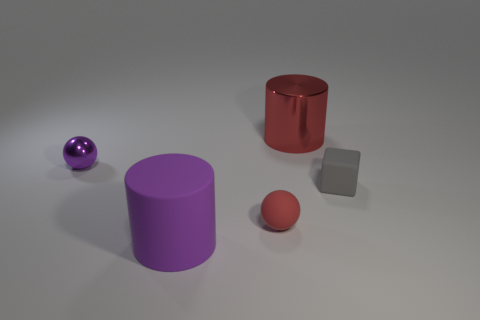Is there any other thing that has the same size as the red matte ball?
Provide a succinct answer. Yes. What size is the purple matte cylinder?
Provide a succinct answer. Large. How many big things are either rubber cubes or red metal balls?
Your response must be concise. 0. There is a purple shiny sphere; is it the same size as the cylinder on the right side of the big rubber object?
Give a very brief answer. No. Is there anything else that has the same shape as the purple metal thing?
Make the answer very short. Yes. How many gray matte cubes are there?
Ensure brevity in your answer.  1. How many cyan objects are large things or tiny rubber balls?
Make the answer very short. 0. Do the red object behind the red sphere and the small purple thing have the same material?
Offer a terse response. Yes. How many other things are there of the same material as the gray block?
Keep it short and to the point. 2. What material is the gray thing?
Your answer should be compact. Rubber. 